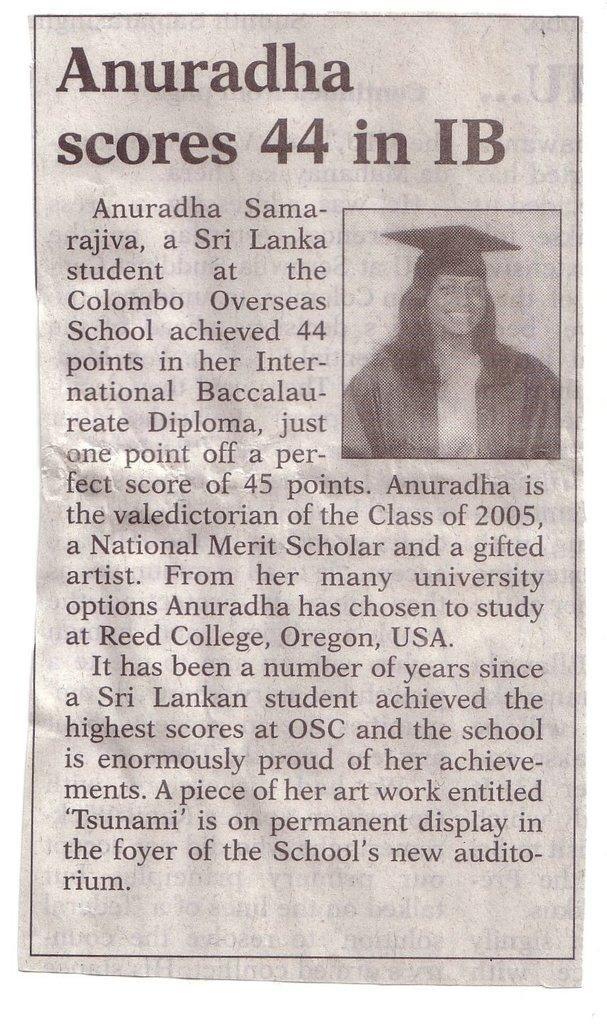Describe this image in one or two sentences. In this image I can see a person and a text. This image looks like a paper cutting. 